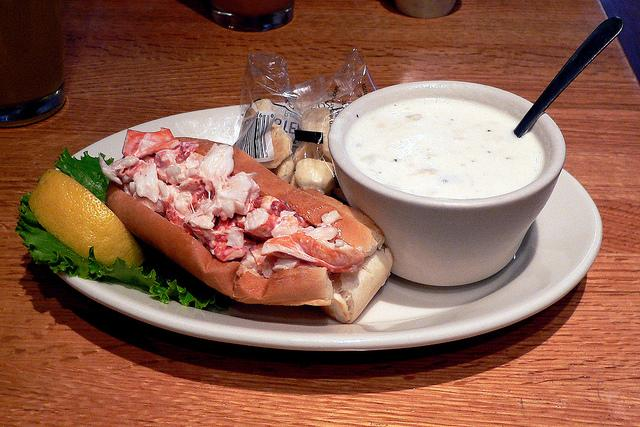What kind of citrus fruit is on top of the leaf on the right side of the white plate? Please explain your reasoning. lemon. The fruit is a lemon. 